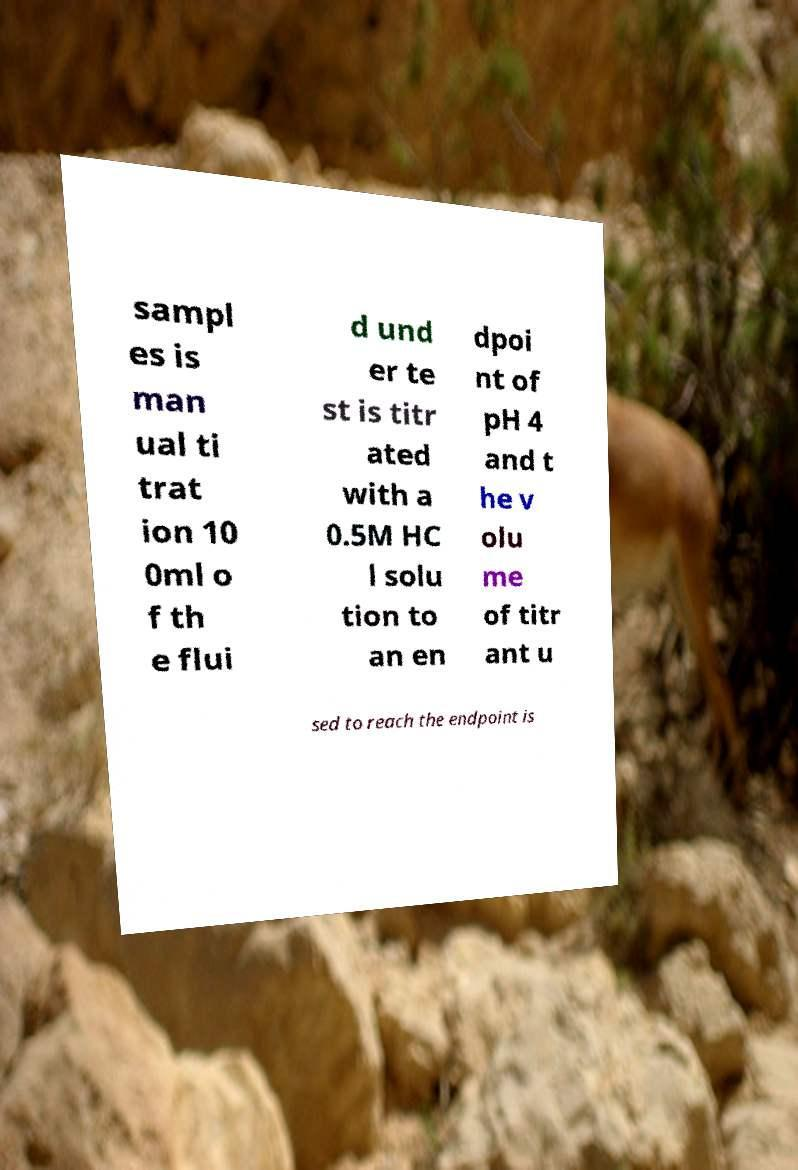Please read and relay the text visible in this image. What does it say? sampl es is man ual ti trat ion 10 0ml o f th e flui d und er te st is titr ated with a 0.5M HC l solu tion to an en dpoi nt of pH 4 and t he v olu me of titr ant u sed to reach the endpoint is 